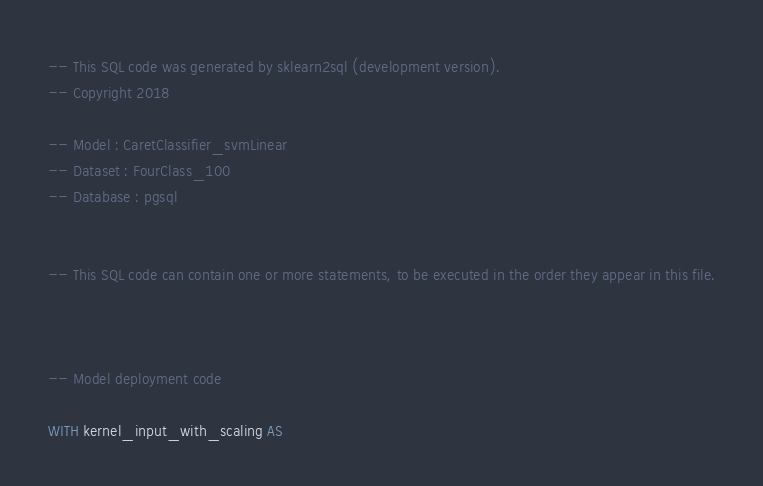<code> <loc_0><loc_0><loc_500><loc_500><_SQL_>-- This SQL code was generated by sklearn2sql (development version).
-- Copyright 2018

-- Model : CaretClassifier_svmLinear
-- Dataset : FourClass_100
-- Database : pgsql


-- This SQL code can contain one or more statements, to be executed in the order they appear in this file.



-- Model deployment code

WITH kernel_input_with_scaling AS </code> 